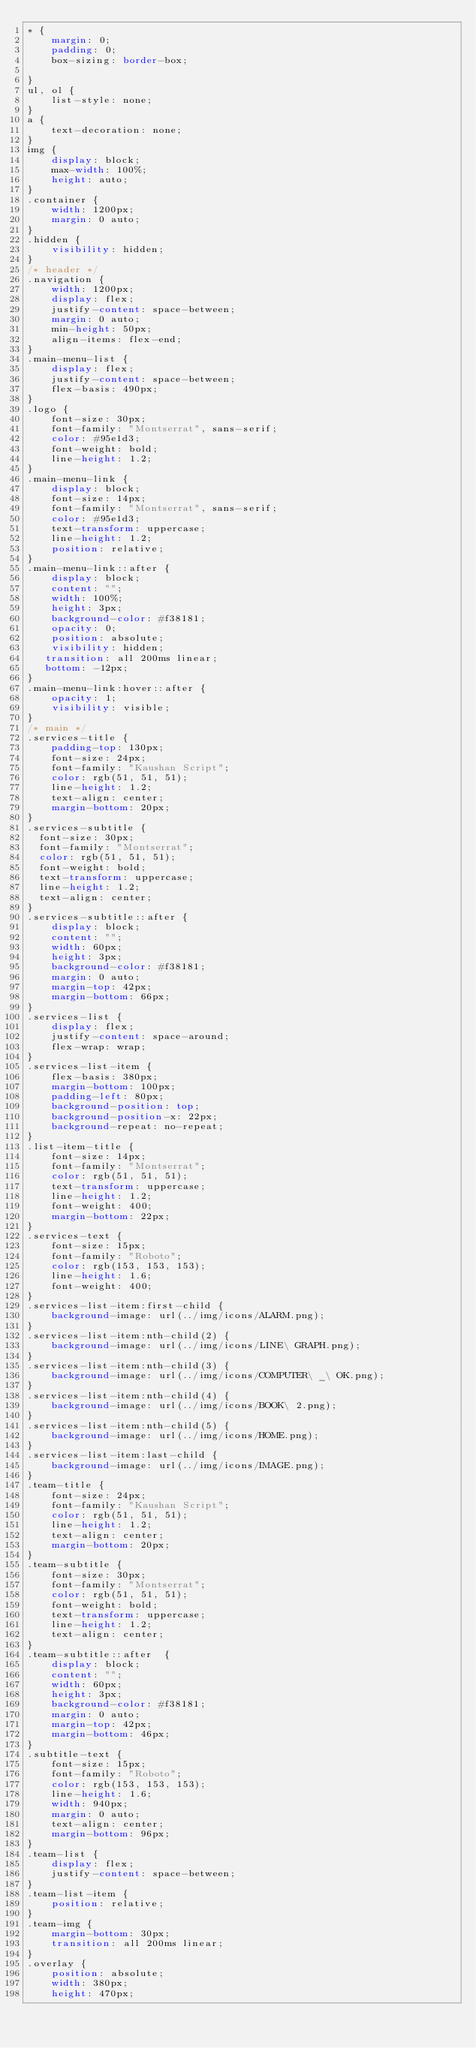<code> <loc_0><loc_0><loc_500><loc_500><_CSS_>* {
    margin: 0;
    padding: 0;
    box-sizing: border-box;

}
ul, ol {
    list-style: none;
}
a {
    text-decoration: none;
}
img {
    display: block;
    max-width: 100%;
    height: auto;
}
.container {
    width: 1200px;
    margin: 0 auto;
}
.hidden {
    visibility: hidden;
}
/* header */
.navigation {
    width: 1200px;
    display: flex;
    justify-content: space-between;
    margin: 0 auto;
    min-height: 50px;
    align-items: flex-end;
}
.main-menu-list {
    display: flex;
    justify-content: space-between;
    flex-basis: 490px;
}
.logo {
    font-size: 30px;
    font-family: "Montserrat", sans-serif;
    color: #95e1d3;
    font-weight: bold;
    line-height: 1.2;
}
.main-menu-link {
    display: block;
    font-size: 14px;
    font-family: "Montserrat", sans-serif;
    color: #95e1d3;
    text-transform: uppercase;
    line-height: 1.2;
    position: relative;
}
.main-menu-link::after {
    display: block;
    content: "";
    width: 100%;
    height: 3px;
    background-color: #f38181;
    opacity: 0;
    position: absolute;
    visibility: hidden;
   transition: all 200ms linear;
   bottom: -12px;
}
.main-menu-link:hover::after {
    opacity: 1;
    visibility: visible;
}
/* main */
.services-title {
    padding-top: 130px;
    font-size: 24px;
    font-family: "Kaushan Script";
    color: rgb(51, 51, 51);
    line-height: 1.2;
    text-align: center;
    margin-bottom: 20px;
}
.services-subtitle {
  font-size: 30px;
  font-family: "Montserrat";
  color: rgb(51, 51, 51);
  font-weight: bold;
  text-transform: uppercase;
  line-height: 1.2;
  text-align: center;
}
.services-subtitle::after {
    display: block;
    content: "";
    width: 60px;
    height: 3px;
    background-color: #f38181;
    margin: 0 auto;
    margin-top: 42px;
    margin-bottom: 66px;
}
.services-list {
    display: flex;
    justify-content: space-around;
    flex-wrap: wrap;
}
.services-list-item {
    flex-basis: 380px;
    margin-bottom: 100px;
    padding-left: 80px;
    background-position: top;
    background-position-x: 22px;
    background-repeat: no-repeat;
}
.list-item-title {
    font-size: 14px;
    font-family: "Montserrat";
    color: rgb(51, 51, 51);
    text-transform: uppercase;
    line-height: 1.2;
    font-weight: 400;
    margin-bottom: 22px;
}
.services-text {
    font-size: 15px;
    font-family: "Roboto";
    color: rgb(153, 153, 153);
    line-height: 1.6;
    font-weight: 400;
}
.services-list-item:first-child {
    background-image: url(../img/icons/ALARM.png);
}
.services-list-item:nth-child(2) {
    background-image: url(../img/icons/LINE\ GRAPH.png);
}
.services-list-item:nth-child(3) {
    background-image: url(../img/icons/COMPUTER\ _\ OK.png);
}
.services-list-item:nth-child(4) {
    background-image: url(../img/icons/BOOK\ 2.png);
}
.services-list-item:nth-child(5) {
    background-image: url(../img/icons/HOME.png);
}
.services-list-item:last-child {
    background-image: url(../img/icons/IMAGE.png);
}
.team-title {
    font-size: 24px;
    font-family: "Kaushan Script";
    color: rgb(51, 51, 51);
    line-height: 1.2;
    text-align: center;
    margin-bottom: 20px;
}
.team-subtitle {
    font-size: 30px;
    font-family: "Montserrat";
    color: rgb(51, 51, 51);
    font-weight: bold;
    text-transform: uppercase;
    line-height: 1.2;
    text-align: center;
}
.team-subtitle::after  {
    display: block;
    content: "";
    width: 60px;
    height: 3px;
    background-color: #f38181;
    margin: 0 auto;
    margin-top: 42px;
    margin-bottom: 46px;
}
.subtitle-text {
    font-size: 15px;
    font-family: "Roboto";
    color: rgb(153, 153, 153);
    line-height: 1.6;
    width: 940px;
    margin: 0 auto;
    text-align: center;
    margin-bottom: 96px;
}
.team-list {
    display: flex;
    justify-content: space-between;
}
.team-list-item {
    position: relative;
}
.team-img {
    margin-bottom: 30px;  
    transition: all 200ms linear;
}
.overlay {
    position: absolute;
    width: 380px;
    height: 470px;</code> 